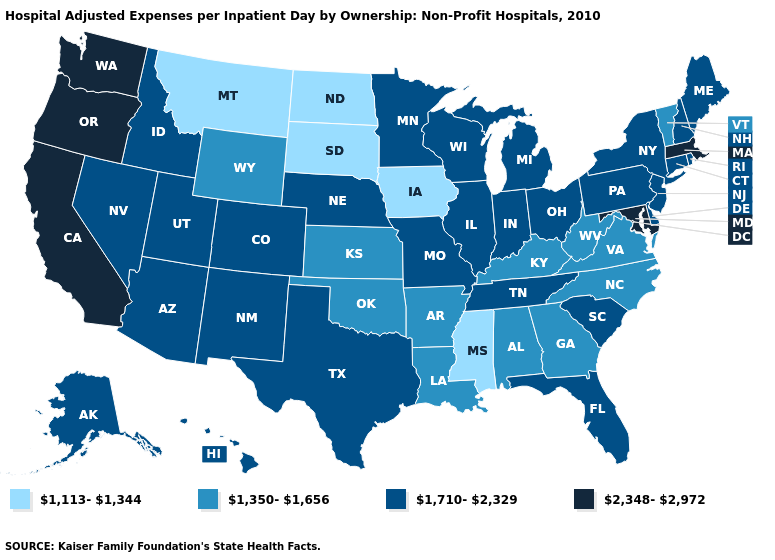Name the states that have a value in the range 1,710-2,329?
Answer briefly. Alaska, Arizona, Colorado, Connecticut, Delaware, Florida, Hawaii, Idaho, Illinois, Indiana, Maine, Michigan, Minnesota, Missouri, Nebraska, Nevada, New Hampshire, New Jersey, New Mexico, New York, Ohio, Pennsylvania, Rhode Island, South Carolina, Tennessee, Texas, Utah, Wisconsin. Among the states that border Texas , does Arkansas have the highest value?
Give a very brief answer. No. Does the first symbol in the legend represent the smallest category?
Be succinct. Yes. Does Montana have the same value as South Dakota?
Give a very brief answer. Yes. Does Washington have the highest value in the USA?
Quick response, please. Yes. Does the map have missing data?
Give a very brief answer. No. What is the highest value in states that border New Hampshire?
Concise answer only. 2,348-2,972. Name the states that have a value in the range 1,350-1,656?
Keep it brief. Alabama, Arkansas, Georgia, Kansas, Kentucky, Louisiana, North Carolina, Oklahoma, Vermont, Virginia, West Virginia, Wyoming. Name the states that have a value in the range 1,350-1,656?
Give a very brief answer. Alabama, Arkansas, Georgia, Kansas, Kentucky, Louisiana, North Carolina, Oklahoma, Vermont, Virginia, West Virginia, Wyoming. Among the states that border Pennsylvania , which have the highest value?
Write a very short answer. Maryland. Does South Carolina have a lower value than Delaware?
Short answer required. No. What is the value of Louisiana?
Concise answer only. 1,350-1,656. What is the lowest value in states that border Montana?
Answer briefly. 1,113-1,344. Does New Jersey have the lowest value in the USA?
Answer briefly. No. What is the value of Louisiana?
Answer briefly. 1,350-1,656. 